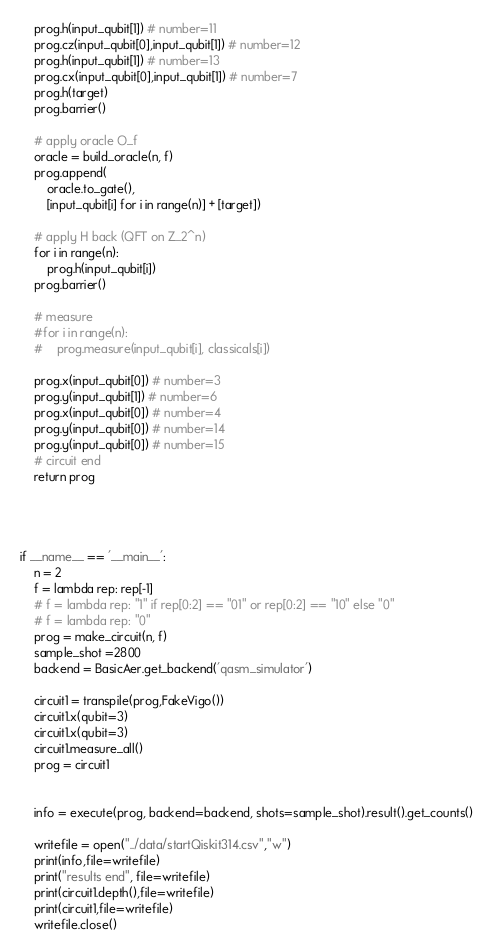Convert code to text. <code><loc_0><loc_0><loc_500><loc_500><_Python_>    prog.h(input_qubit[1]) # number=11
    prog.cz(input_qubit[0],input_qubit[1]) # number=12
    prog.h(input_qubit[1]) # number=13
    prog.cx(input_qubit[0],input_qubit[1]) # number=7
    prog.h(target)
    prog.barrier()

    # apply oracle O_f
    oracle = build_oracle(n, f)
    prog.append(
        oracle.to_gate(),
        [input_qubit[i] for i in range(n)] + [target])

    # apply H back (QFT on Z_2^n)
    for i in range(n):
        prog.h(input_qubit[i])
    prog.barrier()

    # measure
    #for i in range(n):
    #    prog.measure(input_qubit[i], classicals[i])

    prog.x(input_qubit[0]) # number=3
    prog.y(input_qubit[1]) # number=6
    prog.x(input_qubit[0]) # number=4
    prog.y(input_qubit[0]) # number=14
    prog.y(input_qubit[0]) # number=15
    # circuit end
    return prog




if __name__ == '__main__':
    n = 2
    f = lambda rep: rep[-1]
    # f = lambda rep: "1" if rep[0:2] == "01" or rep[0:2] == "10" else "0"
    # f = lambda rep: "0"
    prog = make_circuit(n, f)
    sample_shot =2800
    backend = BasicAer.get_backend('qasm_simulator')

    circuit1 = transpile(prog,FakeVigo())
    circuit1.x(qubit=3)
    circuit1.x(qubit=3)
    circuit1.measure_all()
    prog = circuit1


    info = execute(prog, backend=backend, shots=sample_shot).result().get_counts()

    writefile = open("../data/startQiskit314.csv","w")
    print(info,file=writefile)
    print("results end", file=writefile)
    print(circuit1.depth(),file=writefile)
    print(circuit1,file=writefile)
    writefile.close()
</code> 